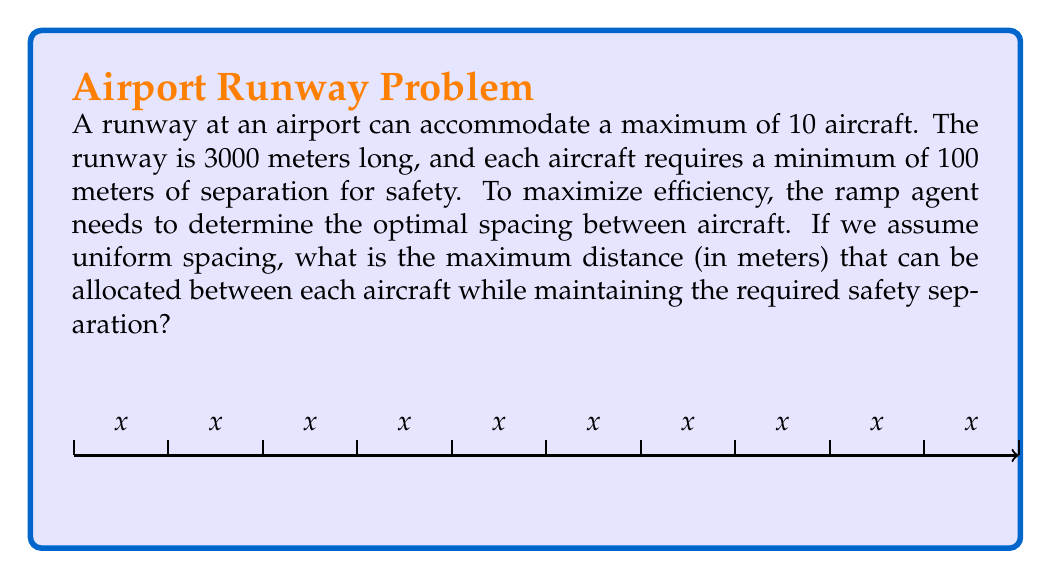Give your solution to this math problem. Let's approach this step-by-step:

1) Let $x$ be the distance between each aircraft (including the aircraft itself).

2) We know there are 10 aircraft, so there will be 9 spaces between them.

3) The total length of the runway is 3000 meters. This can be expressed as:
   $$10x = 3000$$

4) Solving for $x$:
   $$x = \frac{3000}{10} = 300$$

5) So, each aircraft (including its allocated space) occupies 300 meters.

6) To find the actual space between aircraft, we need to subtract the minimum required separation:
   $$\text{Space between aircraft} = 300 - 100 = 200$$

7) We need to verify if this satisfies the minimum separation requirement:
   200 meters > 100 meters, so it does.

Therefore, the maximum distance that can be allocated between each aircraft while maintaining the required safety separation is 200 meters.
Answer: 200 meters 